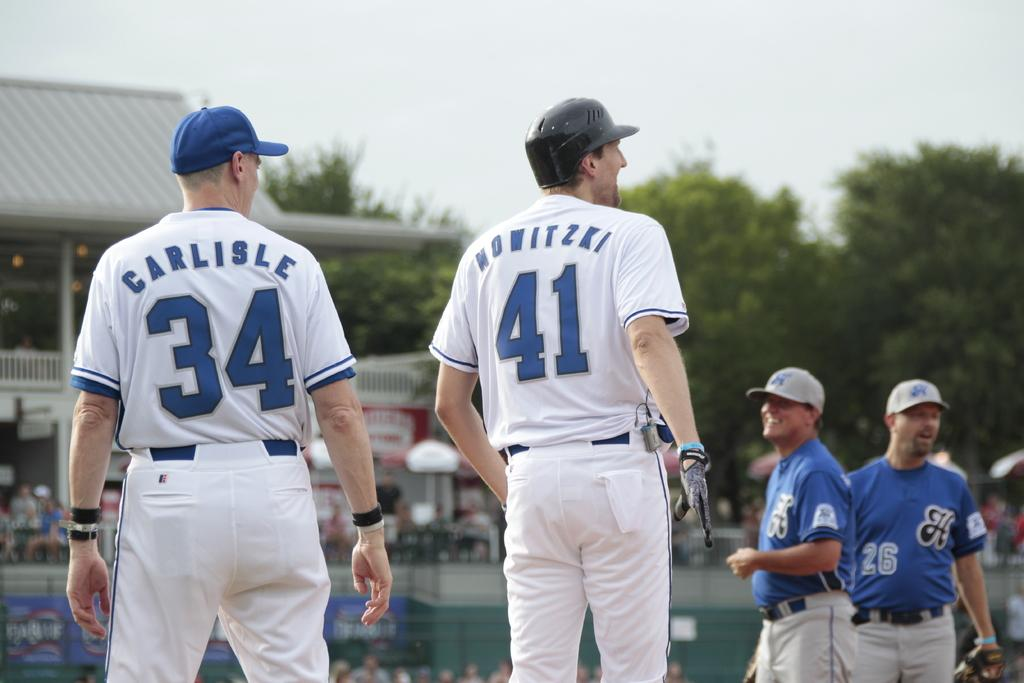Provide a one-sentence caption for the provided image. a couple players with one that has the number 41 on. 